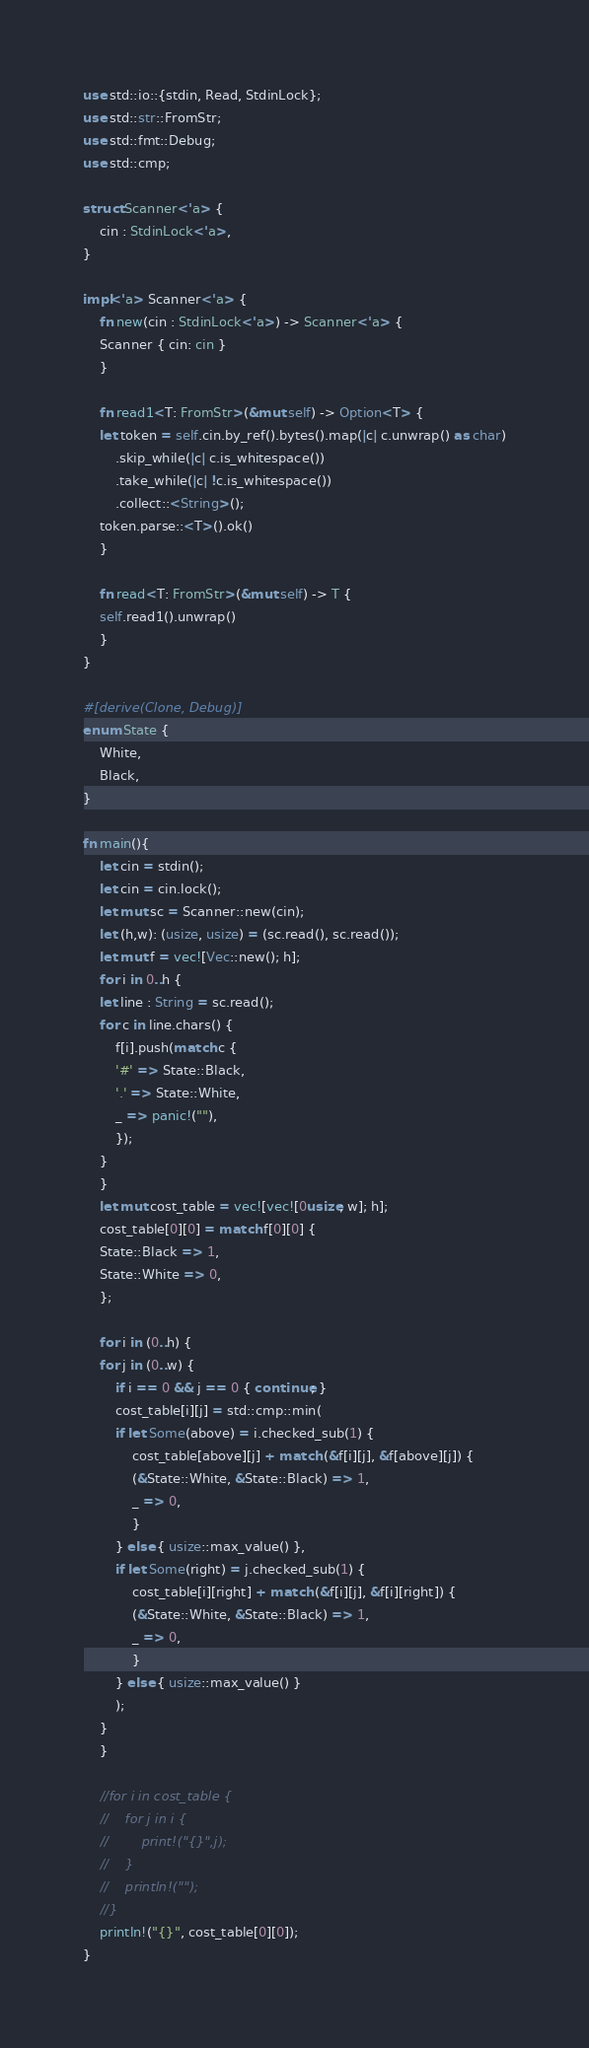<code> <loc_0><loc_0><loc_500><loc_500><_Rust_>use std::io::{stdin, Read, StdinLock};
use std::str::FromStr;
use std::fmt::Debug;
use std::cmp;

struct Scanner<'a> {
    cin : StdinLock<'a>,
}

impl<'a> Scanner<'a> {
    fn new(cin : StdinLock<'a>) -> Scanner<'a> {
	Scanner { cin: cin }
    }

    fn read1<T: FromStr>(&mut self) -> Option<T> {
	let token = self.cin.by_ref().bytes().map(|c| c.unwrap() as char)
	    .skip_while(|c| c.is_whitespace())
	    .take_while(|c| !c.is_whitespace())
	    .collect::<String>();
	token.parse::<T>().ok()
    }

    fn read<T: FromStr>(&mut self) -> T {
	self.read1().unwrap()
    }
}

#[derive(Clone, Debug)]
enum State {
    White,
    Black,
}

fn main(){
    let cin = stdin();
    let cin = cin.lock();
    let mut sc = Scanner::new(cin);
    let (h,w): (usize, usize) = (sc.read(), sc.read());
    let mut f = vec![Vec::new(); h];
    for i in 0..h {
	let line : String = sc.read();
	for c in line.chars() {
	    f[i].push(match c {
		'#' => State::Black,
		'.' => State::White,
		_ => panic!(""),
	    });
	}
    }
    let mut cost_table = vec![vec![0usize; w]; h];
    cost_table[0][0] = match f[0][0] {
	State::Black => 1,
	State::White => 0,
    };

    for i in (0..h) {
	for j in (0..w) {
	    if i == 0 && j == 0 { continue; }
	    cost_table[i][j] = std::cmp::min(
		if let Some(above) = i.checked_sub(1) {
		    cost_table[above][j] + match (&f[i][j], &f[above][j]) {
			(&State::White, &State::Black) => 1,
			_ => 0,
		    }
		} else { usize::max_value() },
		if let Some(right) = j.checked_sub(1) {
		    cost_table[i][right] + match (&f[i][j], &f[i][right]) {
			(&State::White, &State::Black) => 1,
			_ => 0,
		    }
		} else { usize::max_value() }
	    );
	}
    }

    //for i in cost_table {
    //    for j in i {
    //        print!("{}",j);
    //    }
    //    println!("");
    //}
    println!("{}", cost_table[0][0]);
}

</code> 